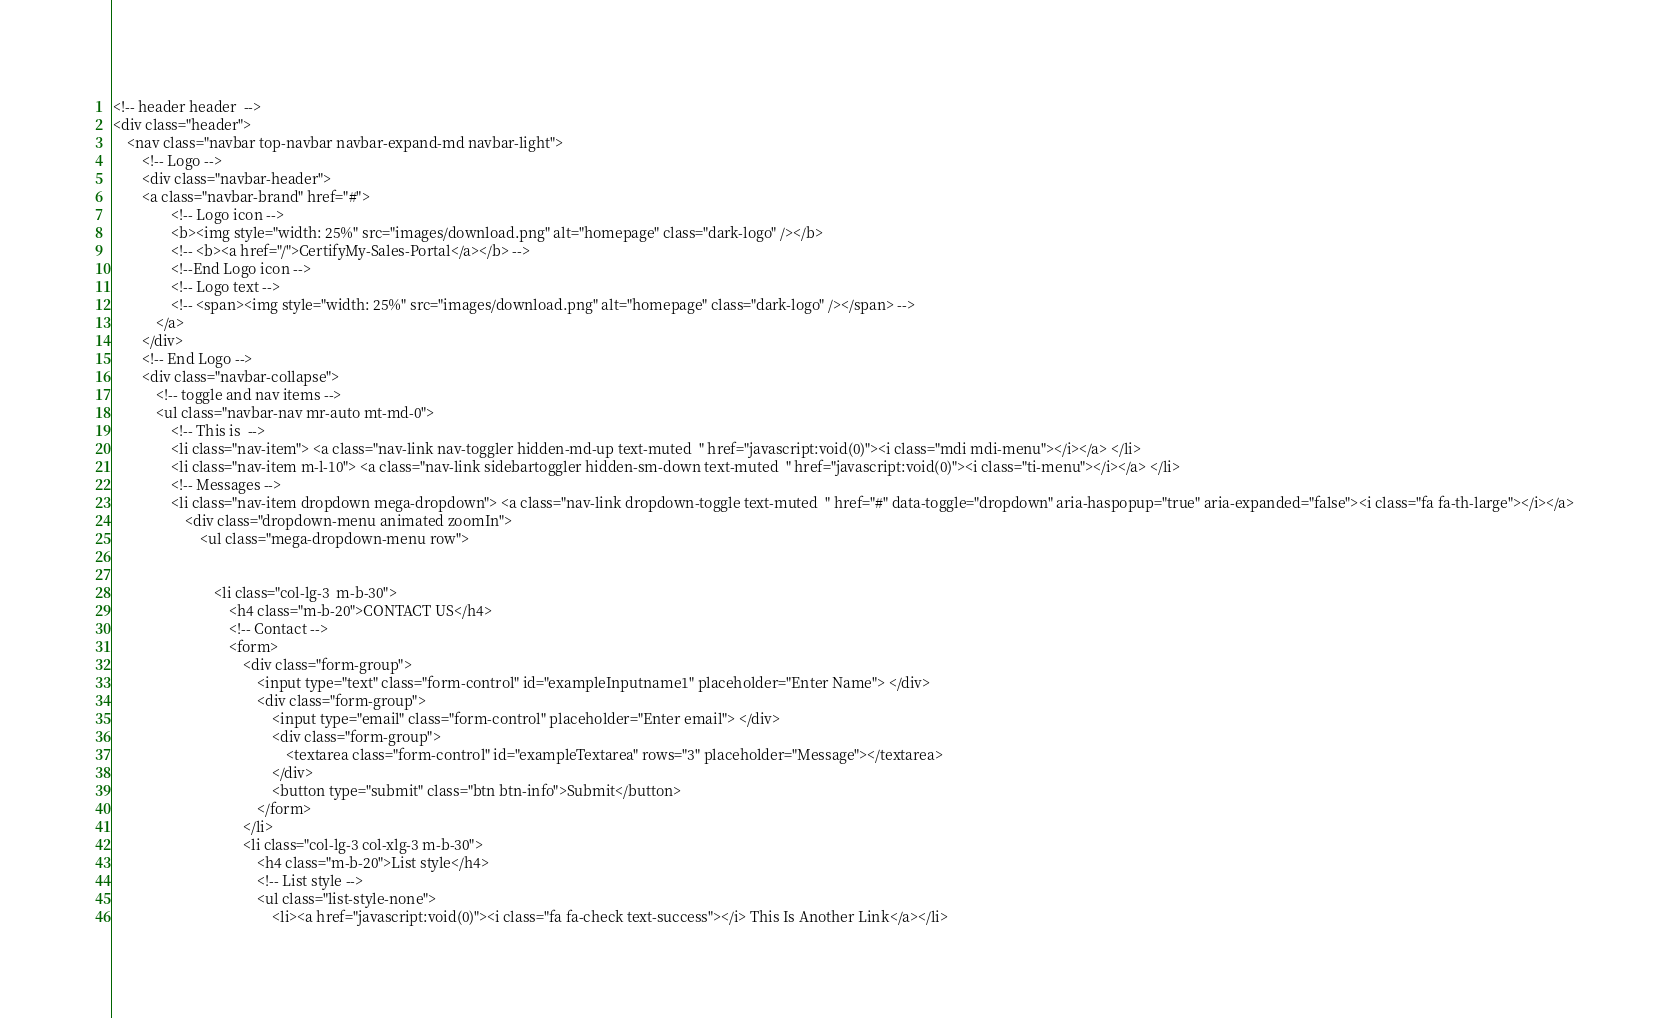<code> <loc_0><loc_0><loc_500><loc_500><_PHP_><!-- header header  -->
<div class="header">
    <nav class="navbar top-navbar navbar-expand-md navbar-light">
        <!-- Logo -->
        <div class="navbar-header">
        <a class="navbar-brand" href="#">
                <!-- Logo icon -->
                <b><img style="width: 25%" src="images/download.png" alt="homepage" class="dark-logo" /></b>
                <!-- <b><a href="/">CertifyMy-Sales-Portal</a></b> -->
                <!--End Logo icon -->
                <!-- Logo text -->
                <!-- <span><img style="width: 25%" src="images/download.png" alt="homepage" class="dark-logo" /></span> -->
            </a>
        </div>
        <!-- End Logo -->
        <div class="navbar-collapse">
            <!-- toggle and nav items -->
            <ul class="navbar-nav mr-auto mt-md-0">
                <!-- This is  -->
                <li class="nav-item"> <a class="nav-link nav-toggler hidden-md-up text-muted  " href="javascript:void(0)"><i class="mdi mdi-menu"></i></a> </li>
                <li class="nav-item m-l-10"> <a class="nav-link sidebartoggler hidden-sm-down text-muted  " href="javascript:void(0)"><i class="ti-menu"></i></a> </li>
                <!-- Messages -->
                <li class="nav-item dropdown mega-dropdown"> <a class="nav-link dropdown-toggle text-muted  " href="#" data-toggle="dropdown" aria-haspopup="true" aria-expanded="false"><i class="fa fa-th-large"></i></a>
                    <div class="dropdown-menu animated zoomIn">
                        <ul class="mega-dropdown-menu row">


                            <li class="col-lg-3  m-b-30">
                                <h4 class="m-b-20">CONTACT US</h4>
                                <!-- Contact -->
                                <form>
                                    <div class="form-group">
                                        <input type="text" class="form-control" id="exampleInputname1" placeholder="Enter Name"> </div>
                                        <div class="form-group">
                                            <input type="email" class="form-control" placeholder="Enter email"> </div>
                                            <div class="form-group">
                                                <textarea class="form-control" id="exampleTextarea" rows="3" placeholder="Message"></textarea>
                                            </div>
                                            <button type="submit" class="btn btn-info">Submit</button>
                                        </form>
                                    </li>
                                    <li class="col-lg-3 col-xlg-3 m-b-30">
                                        <h4 class="m-b-20">List style</h4>
                                        <!-- List style -->
                                        <ul class="list-style-none">
                                            <li><a href="javascript:void(0)"><i class="fa fa-check text-success"></i> This Is Another Link</a></li></code> 